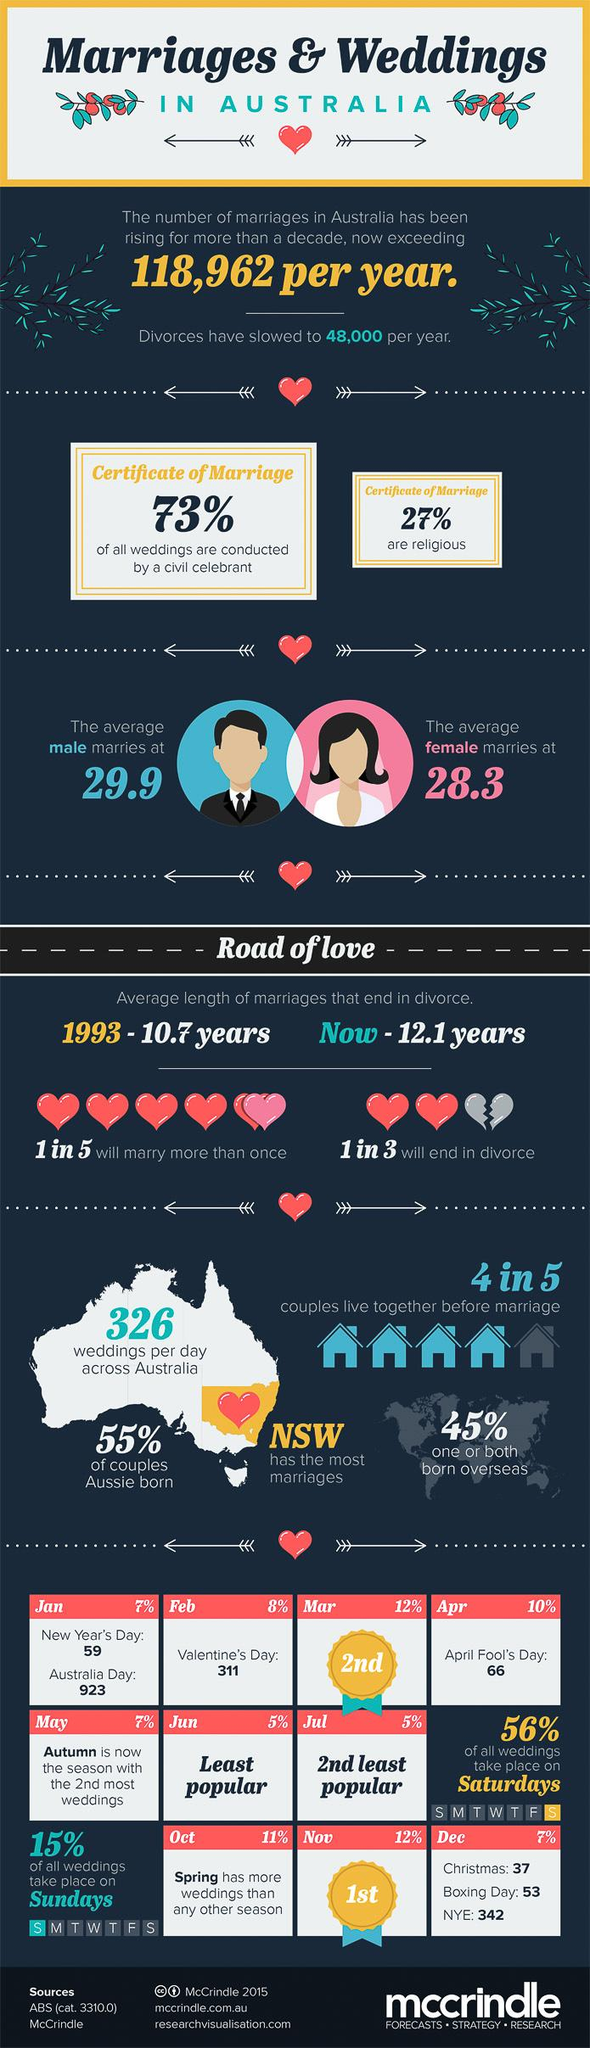Give some essential details in this illustration. According to the given data, approximately 45% of couples are not Australian-born. Approximately 27% of weddings are not conducted by a civil celebrant. Out of 5, how many will only marry once? According to a recent study, 73% of marriage certificates are non-religious. 